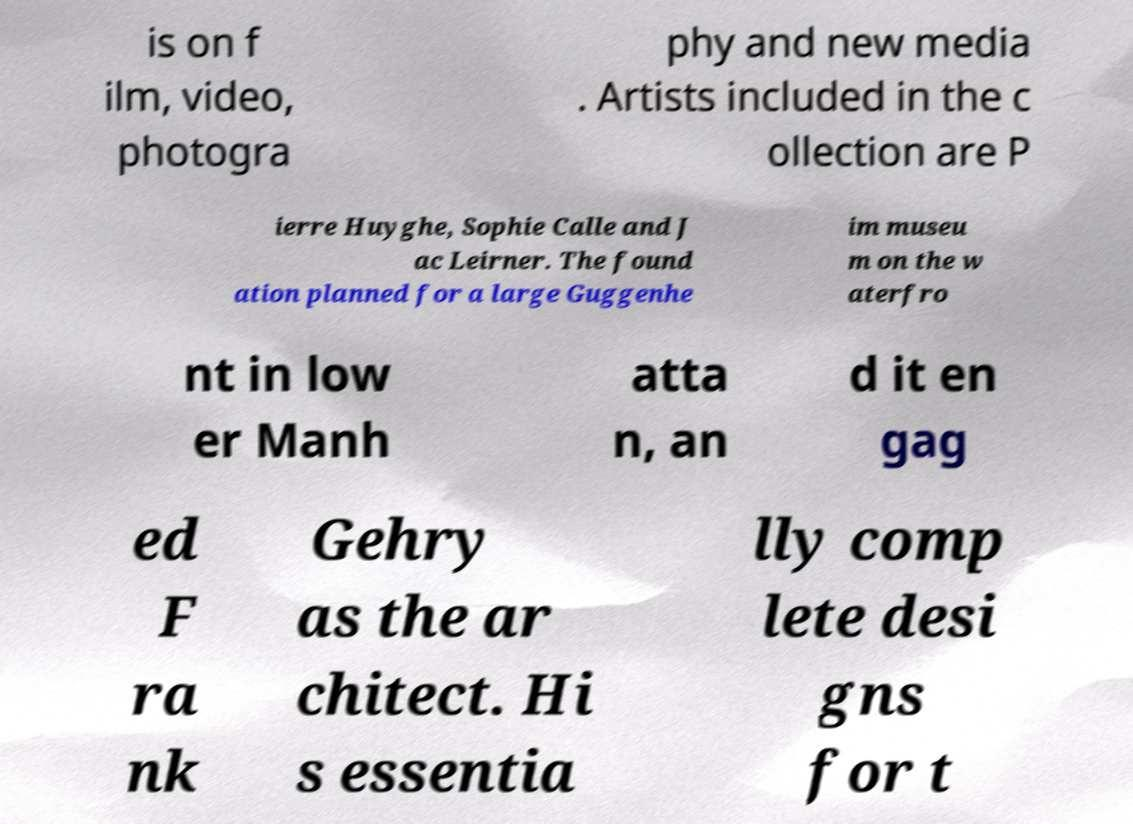For documentation purposes, I need the text within this image transcribed. Could you provide that? is on f ilm, video, photogra phy and new media . Artists included in the c ollection are P ierre Huyghe, Sophie Calle and J ac Leirner. The found ation planned for a large Guggenhe im museu m on the w aterfro nt in low er Manh atta n, an d it en gag ed F ra nk Gehry as the ar chitect. Hi s essentia lly comp lete desi gns for t 